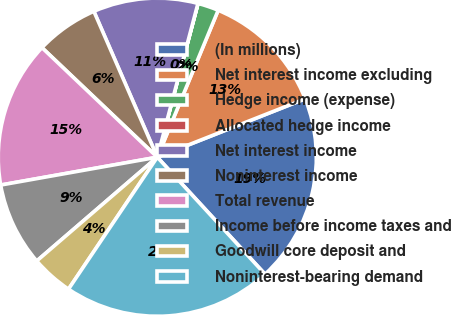<chart> <loc_0><loc_0><loc_500><loc_500><pie_chart><fcel>(In millions)<fcel>Net interest income excluding<fcel>Hedge income (expense)<fcel>Allocated hedge income<fcel>Net interest income<fcel>Noninterest income<fcel>Total revenue<fcel>Income before income taxes and<fcel>Goodwill core deposit and<fcel>Noninterest-bearing demand<nl><fcel>19.14%<fcel>12.76%<fcel>2.13%<fcel>0.01%<fcel>10.64%<fcel>6.38%<fcel>14.89%<fcel>8.51%<fcel>4.26%<fcel>21.27%<nl></chart> 